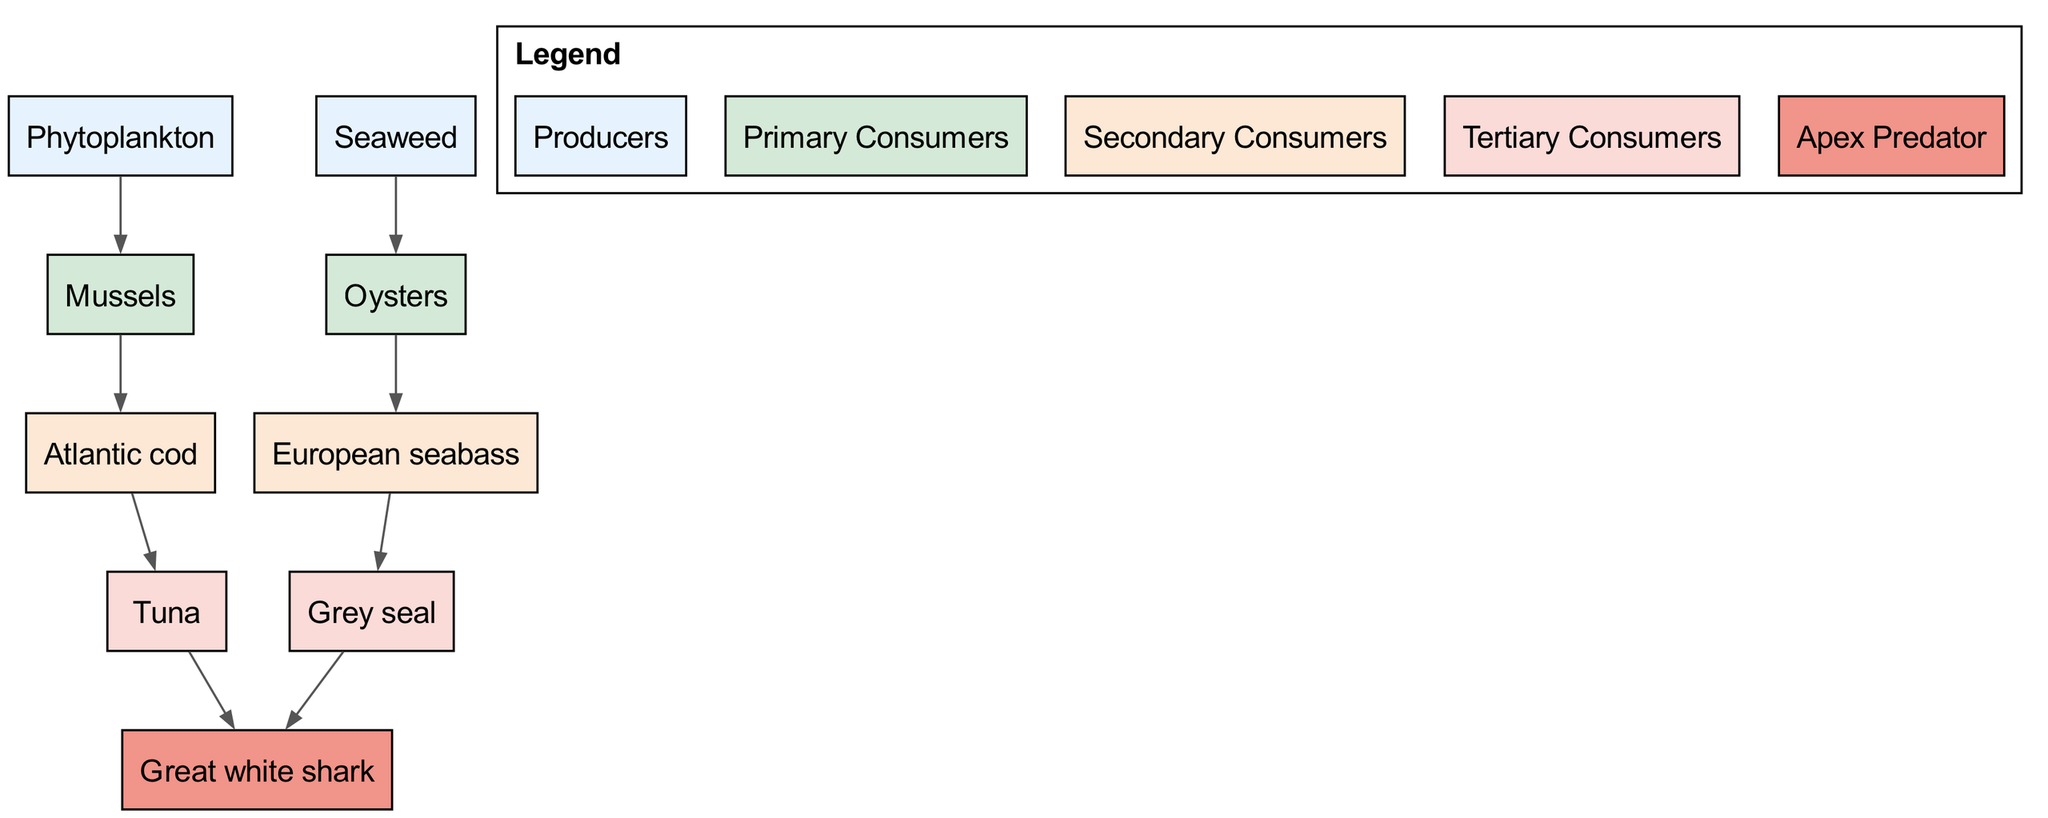What are the producers in this food chain? The diagram indicates "Phytoplankton" and "Seaweed" as the sources of energy in the ecosystem, categorizing them as producers that form the base of the food chain.
Answer: Phytoplankton, Seaweed How many primary consumers are there? By examining the diagram, I count the nodes listed under the primary consumers category, which are "Mussels" and "Oysters," totaling two distinct primary consumers.
Answer: 2 Which species directly feeds on Oysters? The diagram shows a directed edge from "Oysters" to "European seabass," indicating that the European seabass is the species that consumes Oysters.
Answer: European seabass Who is the apex predator in this ecosystem? The apex predator is defined as the organism at the top of the food chain that has no predators. The diagram identifies "Great white shark" as that organism.
Answer: Great white shark How many relationships are shown in the diagram? The diagram outlines several flow relationships between different species. Counting these relationships, I identify a total of eight directed connections between the species.
Answer: 8 What is the relationship between Mussels and Atlantic cod? The diagram clearly indicates that Mussels serve as a food source for Atlantic cod, connecting these two nodes through a directed edge.
Answer: Mussels → Atlantic cod Which species are at the tertiary consumer level? In the diagram, the tertiary consumers are listed as "Tuna" and "Grey seal," making them the primary carnivores that feed on secondary consumers.
Answer: Tuna, Grey seal Which consumer category does the European seabass belong to? The European seabass is included in the secondary consumers group as it directly feeds on primary consumers (specifically Oysters) in the food chain.
Answer: Secondary Consumers What role does Phytoplankton play in this food chain? Phytoplankton serves as a producer, the foundational element of the food chain, capturing energy from sunlight and forming the base of multiple trophic interactions.
Answer: Producer 